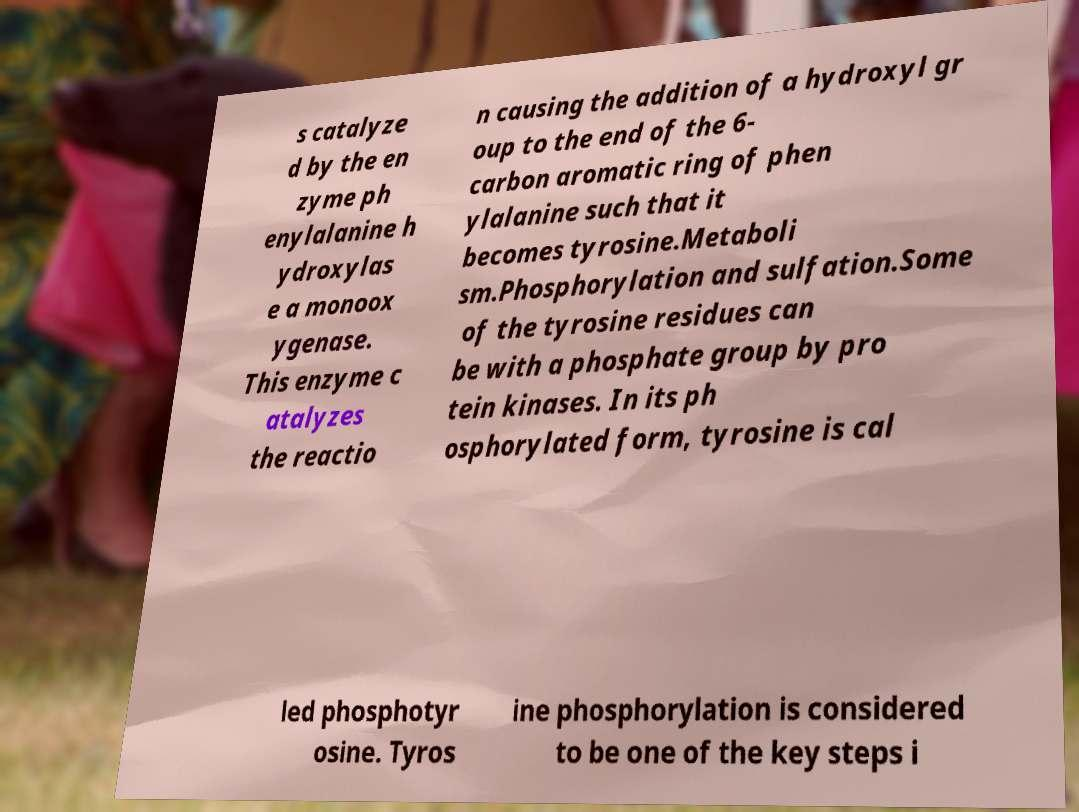Can you accurately transcribe the text from the provided image for me? s catalyze d by the en zyme ph enylalanine h ydroxylas e a monoox ygenase. This enzyme c atalyzes the reactio n causing the addition of a hydroxyl gr oup to the end of the 6- carbon aromatic ring of phen ylalanine such that it becomes tyrosine.Metaboli sm.Phosphorylation and sulfation.Some of the tyrosine residues can be with a phosphate group by pro tein kinases. In its ph osphorylated form, tyrosine is cal led phosphotyr osine. Tyros ine phosphorylation is considered to be one of the key steps i 